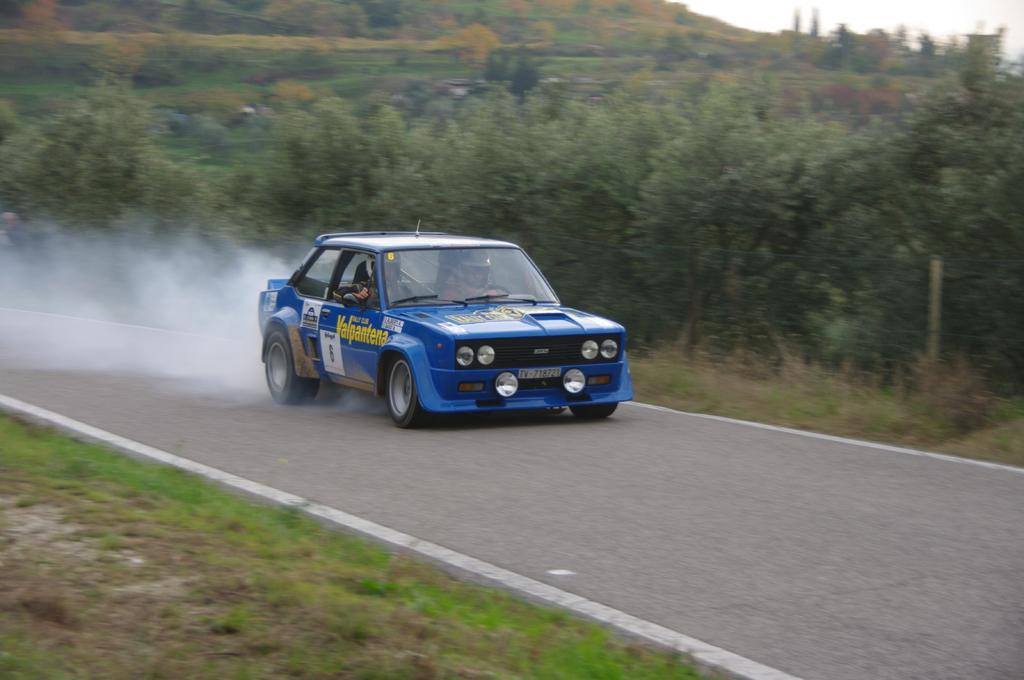What color is the car in the image? The car in the image is blue. Where is the car located in the image? The car is on a road in the image. What can be seen in the background of the image? There are trees and plants in the background of the image. What type of bait is being used to catch fish in the image? There is no bait or fishing activity present in the image; it features a blue car on a road with trees and plants in the background. 